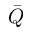<formula> <loc_0><loc_0><loc_500><loc_500>\bar { Q }</formula> 